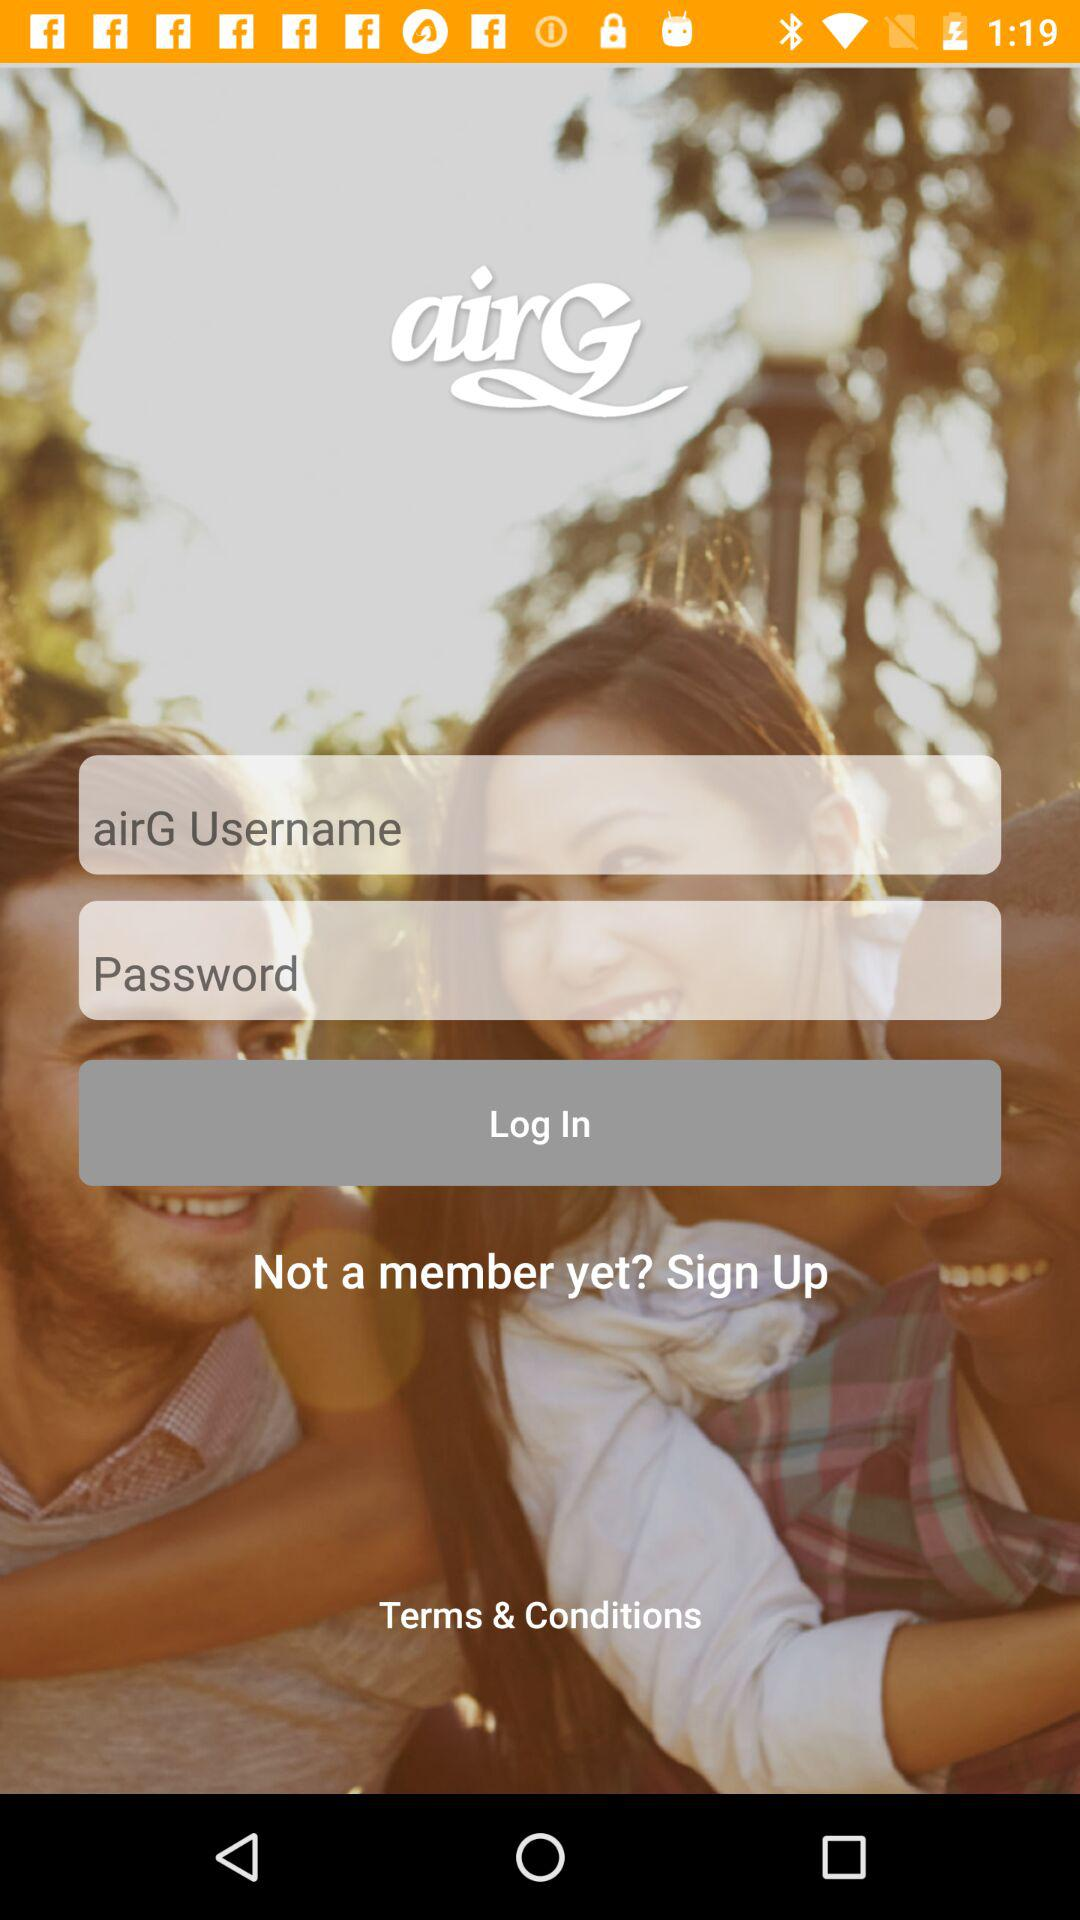What is the app name? The app name is "airG". 